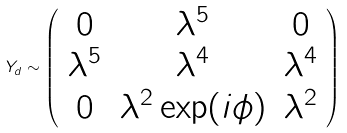Convert formula to latex. <formula><loc_0><loc_0><loc_500><loc_500>Y _ { d } \sim \left ( \begin{array} { c c c } 0 & \lambda ^ { 5 } & 0 \\ \lambda ^ { 5 } & \lambda ^ { 4 } & \lambda ^ { 4 } \\ 0 & \lambda ^ { 2 } \exp ( i \phi ) & \lambda ^ { 2 } \end{array} \right )</formula> 